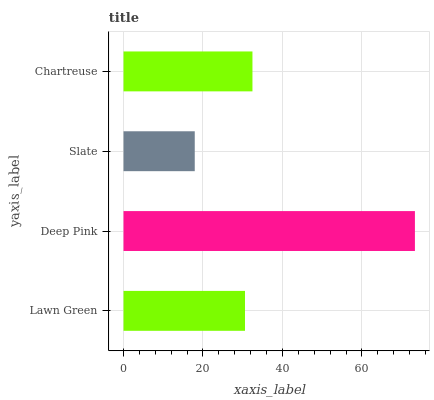Is Slate the minimum?
Answer yes or no. Yes. Is Deep Pink the maximum?
Answer yes or no. Yes. Is Deep Pink the minimum?
Answer yes or no. No. Is Slate the maximum?
Answer yes or no. No. Is Deep Pink greater than Slate?
Answer yes or no. Yes. Is Slate less than Deep Pink?
Answer yes or no. Yes. Is Slate greater than Deep Pink?
Answer yes or no. No. Is Deep Pink less than Slate?
Answer yes or no. No. Is Chartreuse the high median?
Answer yes or no. Yes. Is Lawn Green the low median?
Answer yes or no. Yes. Is Slate the high median?
Answer yes or no. No. Is Deep Pink the low median?
Answer yes or no. No. 